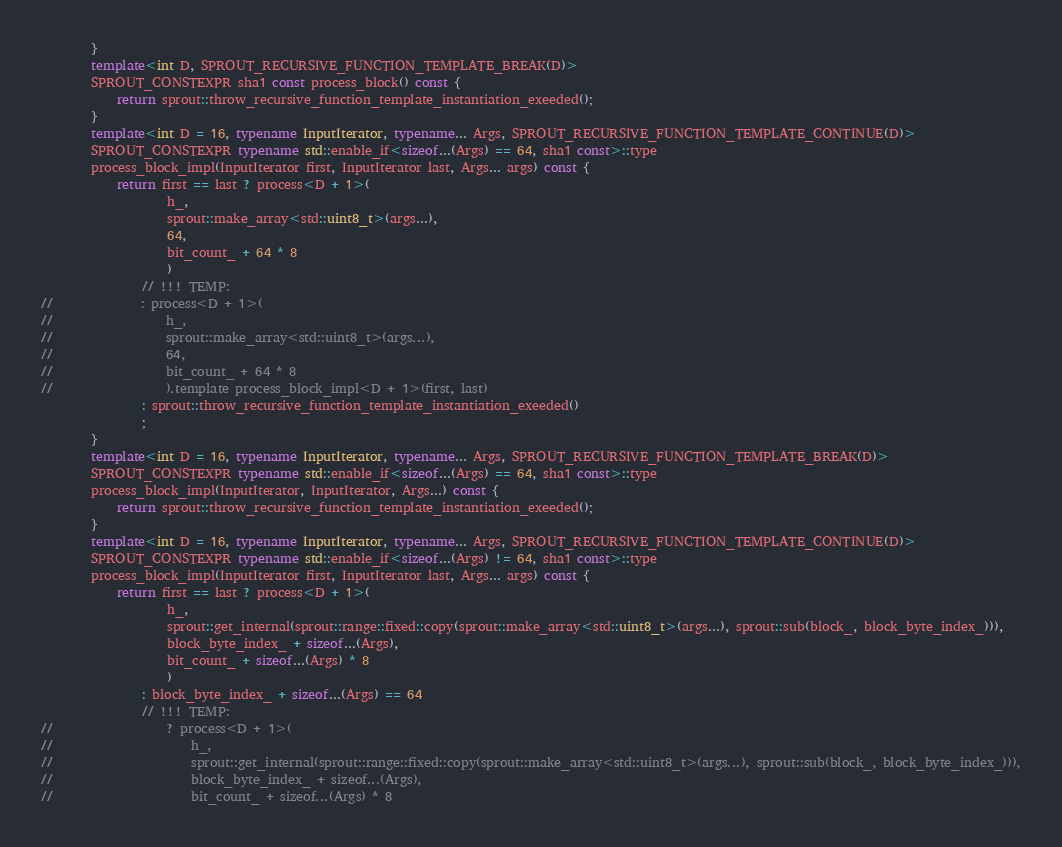<code> <loc_0><loc_0><loc_500><loc_500><_C++_>		}
		template<int D, SPROUT_RECURSIVE_FUNCTION_TEMPLATE_BREAK(D)>
		SPROUT_CONSTEXPR sha1 const process_block() const {
			return sprout::throw_recursive_function_template_instantiation_exeeded();
		}
		template<int D = 16, typename InputIterator, typename... Args, SPROUT_RECURSIVE_FUNCTION_TEMPLATE_CONTINUE(D)>
		SPROUT_CONSTEXPR typename std::enable_if<sizeof...(Args) == 64, sha1 const>::type
		process_block_impl(InputIterator first, InputIterator last, Args... args) const {
			return first == last ? process<D + 1>(
					h_,
					sprout::make_array<std::uint8_t>(args...),
					64,
					bit_count_ + 64 * 8
					)
				// !!! TEMP:
//				: process<D + 1>(
//					h_,
//					sprout::make_array<std::uint8_t>(args...),
//					64,
//					bit_count_ + 64 * 8
//					).template process_block_impl<D + 1>(first, last)
				: sprout::throw_recursive_function_template_instantiation_exeeded()
				;
		}
		template<int D = 16, typename InputIterator, typename... Args, SPROUT_RECURSIVE_FUNCTION_TEMPLATE_BREAK(D)>
		SPROUT_CONSTEXPR typename std::enable_if<sizeof...(Args) == 64, sha1 const>::type
		process_block_impl(InputIterator, InputIterator, Args...) const {
			return sprout::throw_recursive_function_template_instantiation_exeeded();
		}
		template<int D = 16, typename InputIterator, typename... Args, SPROUT_RECURSIVE_FUNCTION_TEMPLATE_CONTINUE(D)>
		SPROUT_CONSTEXPR typename std::enable_if<sizeof...(Args) != 64, sha1 const>::type
		process_block_impl(InputIterator first, InputIterator last, Args... args) const {
			return first == last ? process<D + 1>(
					h_,
					sprout::get_internal(sprout::range::fixed::copy(sprout::make_array<std::uint8_t>(args...), sprout::sub(block_, block_byte_index_))),
					block_byte_index_ + sizeof...(Args),
					bit_count_ + sizeof...(Args) * 8
					)
				: block_byte_index_ + sizeof...(Args) == 64
				// !!! TEMP:
//					? process<D + 1>(
//						h_,
//						sprout::get_internal(sprout::range::fixed::copy(sprout::make_array<std::uint8_t>(args...), sprout::sub(block_, block_byte_index_))),
//						block_byte_index_ + sizeof...(Args),
//						bit_count_ + sizeof...(Args) * 8</code> 